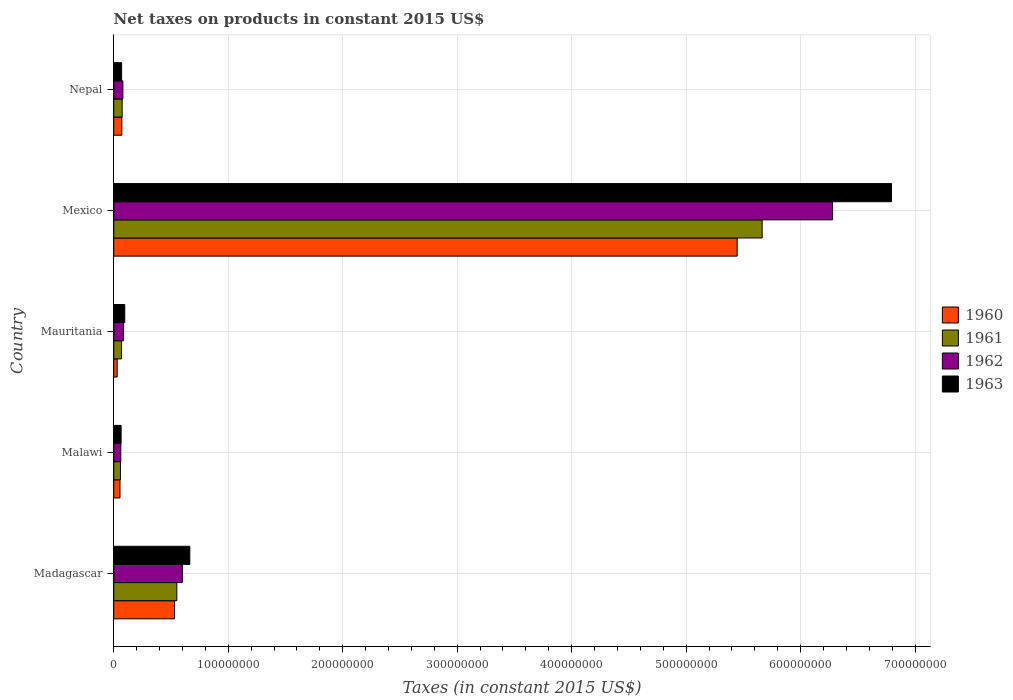Are the number of bars on each tick of the Y-axis equal?
Give a very brief answer. Yes. How many bars are there on the 3rd tick from the bottom?
Keep it short and to the point. 4. What is the label of the 2nd group of bars from the top?
Keep it short and to the point. Mexico. In how many cases, is the number of bars for a given country not equal to the number of legend labels?
Keep it short and to the point. 0. What is the net taxes on products in 1963 in Nepal?
Your response must be concise. 6.89e+06. Across all countries, what is the maximum net taxes on products in 1960?
Provide a short and direct response. 5.45e+08. Across all countries, what is the minimum net taxes on products in 1962?
Your response must be concise. 6.16e+06. In which country was the net taxes on products in 1962 minimum?
Give a very brief answer. Malawi. What is the total net taxes on products in 1961 in the graph?
Give a very brief answer. 6.42e+08. What is the difference between the net taxes on products in 1961 in Mexico and that in Nepal?
Keep it short and to the point. 5.59e+08. What is the difference between the net taxes on products in 1962 in Mauritania and the net taxes on products in 1963 in Nepal?
Give a very brief answer. 1.67e+06. What is the average net taxes on products in 1963 per country?
Provide a succinct answer. 1.54e+08. What is the difference between the net taxes on products in 1963 and net taxes on products in 1962 in Malawi?
Keep it short and to the point. 2.80e+05. In how many countries, is the net taxes on products in 1962 greater than 500000000 US$?
Ensure brevity in your answer.  1. What is the ratio of the net taxes on products in 1963 in Mexico to that in Nepal?
Ensure brevity in your answer.  98.6. Is the difference between the net taxes on products in 1963 in Mauritania and Mexico greater than the difference between the net taxes on products in 1962 in Mauritania and Mexico?
Offer a very short reply. No. What is the difference between the highest and the second highest net taxes on products in 1961?
Offer a terse response. 5.11e+08. What is the difference between the highest and the lowest net taxes on products in 1962?
Give a very brief answer. 6.22e+08. In how many countries, is the net taxes on products in 1960 greater than the average net taxes on products in 1960 taken over all countries?
Offer a very short reply. 1. What does the 3rd bar from the bottom in Madagascar represents?
Your answer should be very brief. 1962. Is it the case that in every country, the sum of the net taxes on products in 1962 and net taxes on products in 1960 is greater than the net taxes on products in 1961?
Provide a succinct answer. Yes. Does the graph contain any zero values?
Provide a succinct answer. No. Does the graph contain grids?
Your response must be concise. Yes. How many legend labels are there?
Offer a terse response. 4. How are the legend labels stacked?
Ensure brevity in your answer.  Vertical. What is the title of the graph?
Make the answer very short. Net taxes on products in constant 2015 US$. Does "1991" appear as one of the legend labels in the graph?
Ensure brevity in your answer.  No. What is the label or title of the X-axis?
Offer a terse response. Taxes (in constant 2015 US$). What is the label or title of the Y-axis?
Offer a very short reply. Country. What is the Taxes (in constant 2015 US$) of 1960 in Madagascar?
Make the answer very short. 5.31e+07. What is the Taxes (in constant 2015 US$) of 1961 in Madagascar?
Ensure brevity in your answer.  5.51e+07. What is the Taxes (in constant 2015 US$) in 1962 in Madagascar?
Your answer should be compact. 6.00e+07. What is the Taxes (in constant 2015 US$) of 1963 in Madagascar?
Your response must be concise. 6.64e+07. What is the Taxes (in constant 2015 US$) of 1960 in Malawi?
Your answer should be compact. 5.46e+06. What is the Taxes (in constant 2015 US$) of 1961 in Malawi?
Provide a succinct answer. 5.88e+06. What is the Taxes (in constant 2015 US$) of 1962 in Malawi?
Give a very brief answer. 6.16e+06. What is the Taxes (in constant 2015 US$) of 1963 in Malawi?
Offer a terse response. 6.44e+06. What is the Taxes (in constant 2015 US$) of 1960 in Mauritania?
Offer a terse response. 3.00e+06. What is the Taxes (in constant 2015 US$) of 1961 in Mauritania?
Make the answer very short. 6.85e+06. What is the Taxes (in constant 2015 US$) of 1962 in Mauritania?
Offer a terse response. 8.56e+06. What is the Taxes (in constant 2015 US$) in 1963 in Mauritania?
Keep it short and to the point. 9.63e+06. What is the Taxes (in constant 2015 US$) of 1960 in Mexico?
Offer a terse response. 5.45e+08. What is the Taxes (in constant 2015 US$) in 1961 in Mexico?
Offer a terse response. 5.66e+08. What is the Taxes (in constant 2015 US$) of 1962 in Mexico?
Your answer should be very brief. 6.28e+08. What is the Taxes (in constant 2015 US$) of 1963 in Mexico?
Provide a succinct answer. 6.79e+08. What is the Taxes (in constant 2015 US$) of 1960 in Nepal?
Make the answer very short. 7.09e+06. What is the Taxes (in constant 2015 US$) in 1961 in Nepal?
Your answer should be compact. 7.35e+06. What is the Taxes (in constant 2015 US$) of 1962 in Nepal?
Make the answer very short. 8.01e+06. What is the Taxes (in constant 2015 US$) in 1963 in Nepal?
Make the answer very short. 6.89e+06. Across all countries, what is the maximum Taxes (in constant 2015 US$) in 1960?
Your answer should be compact. 5.45e+08. Across all countries, what is the maximum Taxes (in constant 2015 US$) of 1961?
Provide a succinct answer. 5.66e+08. Across all countries, what is the maximum Taxes (in constant 2015 US$) in 1962?
Your answer should be very brief. 6.28e+08. Across all countries, what is the maximum Taxes (in constant 2015 US$) in 1963?
Your response must be concise. 6.79e+08. Across all countries, what is the minimum Taxes (in constant 2015 US$) in 1960?
Your response must be concise. 3.00e+06. Across all countries, what is the minimum Taxes (in constant 2015 US$) in 1961?
Give a very brief answer. 5.88e+06. Across all countries, what is the minimum Taxes (in constant 2015 US$) in 1962?
Make the answer very short. 6.16e+06. Across all countries, what is the minimum Taxes (in constant 2015 US$) in 1963?
Ensure brevity in your answer.  6.44e+06. What is the total Taxes (in constant 2015 US$) of 1960 in the graph?
Your answer should be very brief. 6.13e+08. What is the total Taxes (in constant 2015 US$) in 1961 in the graph?
Offer a terse response. 6.42e+08. What is the total Taxes (in constant 2015 US$) in 1962 in the graph?
Your answer should be very brief. 7.11e+08. What is the total Taxes (in constant 2015 US$) of 1963 in the graph?
Provide a succinct answer. 7.69e+08. What is the difference between the Taxes (in constant 2015 US$) in 1960 in Madagascar and that in Malawi?
Make the answer very short. 4.76e+07. What is the difference between the Taxes (in constant 2015 US$) in 1961 in Madagascar and that in Malawi?
Provide a short and direct response. 4.92e+07. What is the difference between the Taxes (in constant 2015 US$) of 1962 in Madagascar and that in Malawi?
Keep it short and to the point. 5.38e+07. What is the difference between the Taxes (in constant 2015 US$) of 1963 in Madagascar and that in Malawi?
Keep it short and to the point. 6.00e+07. What is the difference between the Taxes (in constant 2015 US$) of 1960 in Madagascar and that in Mauritania?
Ensure brevity in your answer.  5.01e+07. What is the difference between the Taxes (in constant 2015 US$) of 1961 in Madagascar and that in Mauritania?
Your answer should be very brief. 4.82e+07. What is the difference between the Taxes (in constant 2015 US$) in 1962 in Madagascar and that in Mauritania?
Make the answer very short. 5.14e+07. What is the difference between the Taxes (in constant 2015 US$) of 1963 in Madagascar and that in Mauritania?
Your answer should be compact. 5.68e+07. What is the difference between the Taxes (in constant 2015 US$) of 1960 in Madagascar and that in Mexico?
Give a very brief answer. -4.91e+08. What is the difference between the Taxes (in constant 2015 US$) of 1961 in Madagascar and that in Mexico?
Provide a succinct answer. -5.11e+08. What is the difference between the Taxes (in constant 2015 US$) in 1962 in Madagascar and that in Mexico?
Offer a very short reply. -5.68e+08. What is the difference between the Taxes (in constant 2015 US$) in 1963 in Madagascar and that in Mexico?
Ensure brevity in your answer.  -6.13e+08. What is the difference between the Taxes (in constant 2015 US$) in 1960 in Madagascar and that in Nepal?
Your answer should be very brief. 4.60e+07. What is the difference between the Taxes (in constant 2015 US$) in 1961 in Madagascar and that in Nepal?
Make the answer very short. 4.77e+07. What is the difference between the Taxes (in constant 2015 US$) in 1962 in Madagascar and that in Nepal?
Your response must be concise. 5.19e+07. What is the difference between the Taxes (in constant 2015 US$) of 1963 in Madagascar and that in Nepal?
Your answer should be compact. 5.95e+07. What is the difference between the Taxes (in constant 2015 US$) of 1960 in Malawi and that in Mauritania?
Your answer should be very brief. 2.46e+06. What is the difference between the Taxes (in constant 2015 US$) in 1961 in Malawi and that in Mauritania?
Provide a short and direct response. -9.67e+05. What is the difference between the Taxes (in constant 2015 US$) in 1962 in Malawi and that in Mauritania?
Make the answer very short. -2.40e+06. What is the difference between the Taxes (in constant 2015 US$) in 1963 in Malawi and that in Mauritania?
Your answer should be compact. -3.19e+06. What is the difference between the Taxes (in constant 2015 US$) in 1960 in Malawi and that in Mexico?
Keep it short and to the point. -5.39e+08. What is the difference between the Taxes (in constant 2015 US$) of 1961 in Malawi and that in Mexico?
Your answer should be compact. -5.61e+08. What is the difference between the Taxes (in constant 2015 US$) of 1962 in Malawi and that in Mexico?
Your response must be concise. -6.22e+08. What is the difference between the Taxes (in constant 2015 US$) of 1963 in Malawi and that in Mexico?
Provide a short and direct response. -6.73e+08. What is the difference between the Taxes (in constant 2015 US$) in 1960 in Malawi and that in Nepal?
Keep it short and to the point. -1.63e+06. What is the difference between the Taxes (in constant 2015 US$) in 1961 in Malawi and that in Nepal?
Ensure brevity in your answer.  -1.47e+06. What is the difference between the Taxes (in constant 2015 US$) in 1962 in Malawi and that in Nepal?
Your answer should be very brief. -1.85e+06. What is the difference between the Taxes (in constant 2015 US$) of 1963 in Malawi and that in Nepal?
Provide a short and direct response. -4.50e+05. What is the difference between the Taxes (in constant 2015 US$) of 1960 in Mauritania and that in Mexico?
Keep it short and to the point. -5.42e+08. What is the difference between the Taxes (in constant 2015 US$) of 1961 in Mauritania and that in Mexico?
Give a very brief answer. -5.60e+08. What is the difference between the Taxes (in constant 2015 US$) of 1962 in Mauritania and that in Mexico?
Your answer should be very brief. -6.19e+08. What is the difference between the Taxes (in constant 2015 US$) in 1963 in Mauritania and that in Mexico?
Make the answer very short. -6.70e+08. What is the difference between the Taxes (in constant 2015 US$) of 1960 in Mauritania and that in Nepal?
Provide a short and direct response. -4.09e+06. What is the difference between the Taxes (in constant 2015 US$) in 1961 in Mauritania and that in Nepal?
Give a very brief answer. -5.03e+05. What is the difference between the Taxes (in constant 2015 US$) in 1962 in Mauritania and that in Nepal?
Provide a succinct answer. 5.53e+05. What is the difference between the Taxes (in constant 2015 US$) of 1963 in Mauritania and that in Nepal?
Give a very brief answer. 2.74e+06. What is the difference between the Taxes (in constant 2015 US$) in 1960 in Mexico and that in Nepal?
Offer a terse response. 5.37e+08. What is the difference between the Taxes (in constant 2015 US$) of 1961 in Mexico and that in Nepal?
Keep it short and to the point. 5.59e+08. What is the difference between the Taxes (in constant 2015 US$) of 1962 in Mexico and that in Nepal?
Offer a terse response. 6.20e+08. What is the difference between the Taxes (in constant 2015 US$) of 1963 in Mexico and that in Nepal?
Keep it short and to the point. 6.72e+08. What is the difference between the Taxes (in constant 2015 US$) in 1960 in Madagascar and the Taxes (in constant 2015 US$) in 1961 in Malawi?
Provide a short and direct response. 4.72e+07. What is the difference between the Taxes (in constant 2015 US$) of 1960 in Madagascar and the Taxes (in constant 2015 US$) of 1962 in Malawi?
Ensure brevity in your answer.  4.69e+07. What is the difference between the Taxes (in constant 2015 US$) of 1960 in Madagascar and the Taxes (in constant 2015 US$) of 1963 in Malawi?
Provide a short and direct response. 4.66e+07. What is the difference between the Taxes (in constant 2015 US$) in 1961 in Madagascar and the Taxes (in constant 2015 US$) in 1962 in Malawi?
Provide a succinct answer. 4.89e+07. What is the difference between the Taxes (in constant 2015 US$) of 1961 in Madagascar and the Taxes (in constant 2015 US$) of 1963 in Malawi?
Provide a succinct answer. 4.87e+07. What is the difference between the Taxes (in constant 2015 US$) in 1962 in Madagascar and the Taxes (in constant 2015 US$) in 1963 in Malawi?
Provide a succinct answer. 5.35e+07. What is the difference between the Taxes (in constant 2015 US$) in 1960 in Madagascar and the Taxes (in constant 2015 US$) in 1961 in Mauritania?
Your response must be concise. 4.62e+07. What is the difference between the Taxes (in constant 2015 US$) in 1960 in Madagascar and the Taxes (in constant 2015 US$) in 1962 in Mauritania?
Ensure brevity in your answer.  4.45e+07. What is the difference between the Taxes (in constant 2015 US$) in 1960 in Madagascar and the Taxes (in constant 2015 US$) in 1963 in Mauritania?
Your response must be concise. 4.34e+07. What is the difference between the Taxes (in constant 2015 US$) of 1961 in Madagascar and the Taxes (in constant 2015 US$) of 1962 in Mauritania?
Your response must be concise. 4.65e+07. What is the difference between the Taxes (in constant 2015 US$) in 1961 in Madagascar and the Taxes (in constant 2015 US$) in 1963 in Mauritania?
Offer a very short reply. 4.55e+07. What is the difference between the Taxes (in constant 2015 US$) of 1962 in Madagascar and the Taxes (in constant 2015 US$) of 1963 in Mauritania?
Keep it short and to the point. 5.03e+07. What is the difference between the Taxes (in constant 2015 US$) in 1960 in Madagascar and the Taxes (in constant 2015 US$) in 1961 in Mexico?
Your response must be concise. -5.13e+08. What is the difference between the Taxes (in constant 2015 US$) in 1960 in Madagascar and the Taxes (in constant 2015 US$) in 1962 in Mexico?
Your response must be concise. -5.75e+08. What is the difference between the Taxes (in constant 2015 US$) of 1960 in Madagascar and the Taxes (in constant 2015 US$) of 1963 in Mexico?
Provide a short and direct response. -6.26e+08. What is the difference between the Taxes (in constant 2015 US$) of 1961 in Madagascar and the Taxes (in constant 2015 US$) of 1962 in Mexico?
Your response must be concise. -5.73e+08. What is the difference between the Taxes (in constant 2015 US$) in 1961 in Madagascar and the Taxes (in constant 2015 US$) in 1963 in Mexico?
Provide a succinct answer. -6.24e+08. What is the difference between the Taxes (in constant 2015 US$) of 1962 in Madagascar and the Taxes (in constant 2015 US$) of 1963 in Mexico?
Offer a very short reply. -6.19e+08. What is the difference between the Taxes (in constant 2015 US$) in 1960 in Madagascar and the Taxes (in constant 2015 US$) in 1961 in Nepal?
Give a very brief answer. 4.57e+07. What is the difference between the Taxes (in constant 2015 US$) in 1960 in Madagascar and the Taxes (in constant 2015 US$) in 1962 in Nepal?
Provide a short and direct response. 4.51e+07. What is the difference between the Taxes (in constant 2015 US$) in 1960 in Madagascar and the Taxes (in constant 2015 US$) in 1963 in Nepal?
Keep it short and to the point. 4.62e+07. What is the difference between the Taxes (in constant 2015 US$) of 1961 in Madagascar and the Taxes (in constant 2015 US$) of 1962 in Nepal?
Ensure brevity in your answer.  4.71e+07. What is the difference between the Taxes (in constant 2015 US$) in 1961 in Madagascar and the Taxes (in constant 2015 US$) in 1963 in Nepal?
Your answer should be compact. 4.82e+07. What is the difference between the Taxes (in constant 2015 US$) in 1962 in Madagascar and the Taxes (in constant 2015 US$) in 1963 in Nepal?
Your answer should be very brief. 5.31e+07. What is the difference between the Taxes (in constant 2015 US$) in 1960 in Malawi and the Taxes (in constant 2015 US$) in 1961 in Mauritania?
Offer a very short reply. -1.39e+06. What is the difference between the Taxes (in constant 2015 US$) in 1960 in Malawi and the Taxes (in constant 2015 US$) in 1962 in Mauritania?
Provide a succinct answer. -3.10e+06. What is the difference between the Taxes (in constant 2015 US$) of 1960 in Malawi and the Taxes (in constant 2015 US$) of 1963 in Mauritania?
Keep it short and to the point. -4.17e+06. What is the difference between the Taxes (in constant 2015 US$) of 1961 in Malawi and the Taxes (in constant 2015 US$) of 1962 in Mauritania?
Ensure brevity in your answer.  -2.68e+06. What is the difference between the Taxes (in constant 2015 US$) in 1961 in Malawi and the Taxes (in constant 2015 US$) in 1963 in Mauritania?
Your answer should be compact. -3.75e+06. What is the difference between the Taxes (in constant 2015 US$) of 1962 in Malawi and the Taxes (in constant 2015 US$) of 1963 in Mauritania?
Provide a short and direct response. -3.47e+06. What is the difference between the Taxes (in constant 2015 US$) in 1960 in Malawi and the Taxes (in constant 2015 US$) in 1961 in Mexico?
Provide a succinct answer. -5.61e+08. What is the difference between the Taxes (in constant 2015 US$) in 1960 in Malawi and the Taxes (in constant 2015 US$) in 1962 in Mexico?
Keep it short and to the point. -6.22e+08. What is the difference between the Taxes (in constant 2015 US$) in 1960 in Malawi and the Taxes (in constant 2015 US$) in 1963 in Mexico?
Provide a succinct answer. -6.74e+08. What is the difference between the Taxes (in constant 2015 US$) in 1961 in Malawi and the Taxes (in constant 2015 US$) in 1962 in Mexico?
Offer a very short reply. -6.22e+08. What is the difference between the Taxes (in constant 2015 US$) of 1961 in Malawi and the Taxes (in constant 2015 US$) of 1963 in Mexico?
Provide a succinct answer. -6.73e+08. What is the difference between the Taxes (in constant 2015 US$) in 1962 in Malawi and the Taxes (in constant 2015 US$) in 1963 in Mexico?
Your response must be concise. -6.73e+08. What is the difference between the Taxes (in constant 2015 US$) in 1960 in Malawi and the Taxes (in constant 2015 US$) in 1961 in Nepal?
Give a very brief answer. -1.89e+06. What is the difference between the Taxes (in constant 2015 US$) in 1960 in Malawi and the Taxes (in constant 2015 US$) in 1962 in Nepal?
Provide a succinct answer. -2.55e+06. What is the difference between the Taxes (in constant 2015 US$) in 1960 in Malawi and the Taxes (in constant 2015 US$) in 1963 in Nepal?
Keep it short and to the point. -1.43e+06. What is the difference between the Taxes (in constant 2015 US$) in 1961 in Malawi and the Taxes (in constant 2015 US$) in 1962 in Nepal?
Keep it short and to the point. -2.13e+06. What is the difference between the Taxes (in constant 2015 US$) in 1961 in Malawi and the Taxes (in constant 2015 US$) in 1963 in Nepal?
Ensure brevity in your answer.  -1.01e+06. What is the difference between the Taxes (in constant 2015 US$) in 1962 in Malawi and the Taxes (in constant 2015 US$) in 1963 in Nepal?
Keep it short and to the point. -7.30e+05. What is the difference between the Taxes (in constant 2015 US$) in 1960 in Mauritania and the Taxes (in constant 2015 US$) in 1961 in Mexico?
Ensure brevity in your answer.  -5.63e+08. What is the difference between the Taxes (in constant 2015 US$) of 1960 in Mauritania and the Taxes (in constant 2015 US$) of 1962 in Mexico?
Your answer should be very brief. -6.25e+08. What is the difference between the Taxes (in constant 2015 US$) of 1960 in Mauritania and the Taxes (in constant 2015 US$) of 1963 in Mexico?
Your response must be concise. -6.76e+08. What is the difference between the Taxes (in constant 2015 US$) of 1961 in Mauritania and the Taxes (in constant 2015 US$) of 1962 in Mexico?
Your answer should be very brief. -6.21e+08. What is the difference between the Taxes (in constant 2015 US$) in 1961 in Mauritania and the Taxes (in constant 2015 US$) in 1963 in Mexico?
Give a very brief answer. -6.73e+08. What is the difference between the Taxes (in constant 2015 US$) in 1962 in Mauritania and the Taxes (in constant 2015 US$) in 1963 in Mexico?
Keep it short and to the point. -6.71e+08. What is the difference between the Taxes (in constant 2015 US$) in 1960 in Mauritania and the Taxes (in constant 2015 US$) in 1961 in Nepal?
Your answer should be very brief. -4.35e+06. What is the difference between the Taxes (in constant 2015 US$) of 1960 in Mauritania and the Taxes (in constant 2015 US$) of 1962 in Nepal?
Keep it short and to the point. -5.01e+06. What is the difference between the Taxes (in constant 2015 US$) of 1960 in Mauritania and the Taxes (in constant 2015 US$) of 1963 in Nepal?
Your response must be concise. -3.89e+06. What is the difference between the Taxes (in constant 2015 US$) of 1961 in Mauritania and the Taxes (in constant 2015 US$) of 1962 in Nepal?
Offer a terse response. -1.16e+06. What is the difference between the Taxes (in constant 2015 US$) of 1961 in Mauritania and the Taxes (in constant 2015 US$) of 1963 in Nepal?
Your answer should be compact. -4.29e+04. What is the difference between the Taxes (in constant 2015 US$) of 1962 in Mauritania and the Taxes (in constant 2015 US$) of 1963 in Nepal?
Ensure brevity in your answer.  1.67e+06. What is the difference between the Taxes (in constant 2015 US$) in 1960 in Mexico and the Taxes (in constant 2015 US$) in 1961 in Nepal?
Offer a terse response. 5.37e+08. What is the difference between the Taxes (in constant 2015 US$) of 1960 in Mexico and the Taxes (in constant 2015 US$) of 1962 in Nepal?
Provide a short and direct response. 5.37e+08. What is the difference between the Taxes (in constant 2015 US$) in 1960 in Mexico and the Taxes (in constant 2015 US$) in 1963 in Nepal?
Provide a short and direct response. 5.38e+08. What is the difference between the Taxes (in constant 2015 US$) in 1961 in Mexico and the Taxes (in constant 2015 US$) in 1962 in Nepal?
Your answer should be compact. 5.58e+08. What is the difference between the Taxes (in constant 2015 US$) of 1961 in Mexico and the Taxes (in constant 2015 US$) of 1963 in Nepal?
Offer a terse response. 5.60e+08. What is the difference between the Taxes (in constant 2015 US$) of 1962 in Mexico and the Taxes (in constant 2015 US$) of 1963 in Nepal?
Offer a very short reply. 6.21e+08. What is the average Taxes (in constant 2015 US$) of 1960 per country?
Offer a terse response. 1.23e+08. What is the average Taxes (in constant 2015 US$) of 1961 per country?
Your answer should be compact. 1.28e+08. What is the average Taxes (in constant 2015 US$) in 1962 per country?
Offer a terse response. 1.42e+08. What is the average Taxes (in constant 2015 US$) of 1963 per country?
Make the answer very short. 1.54e+08. What is the difference between the Taxes (in constant 2015 US$) in 1960 and Taxes (in constant 2015 US$) in 1961 in Madagascar?
Your answer should be very brief. -2.03e+06. What is the difference between the Taxes (in constant 2015 US$) of 1960 and Taxes (in constant 2015 US$) of 1962 in Madagascar?
Make the answer very short. -6.89e+06. What is the difference between the Taxes (in constant 2015 US$) in 1960 and Taxes (in constant 2015 US$) in 1963 in Madagascar?
Give a very brief answer. -1.34e+07. What is the difference between the Taxes (in constant 2015 US$) of 1961 and Taxes (in constant 2015 US$) of 1962 in Madagascar?
Offer a very short reply. -4.86e+06. What is the difference between the Taxes (in constant 2015 US$) of 1961 and Taxes (in constant 2015 US$) of 1963 in Madagascar?
Ensure brevity in your answer.  -1.13e+07. What is the difference between the Taxes (in constant 2015 US$) of 1962 and Taxes (in constant 2015 US$) of 1963 in Madagascar?
Your response must be concise. -6.48e+06. What is the difference between the Taxes (in constant 2015 US$) in 1960 and Taxes (in constant 2015 US$) in 1961 in Malawi?
Give a very brief answer. -4.20e+05. What is the difference between the Taxes (in constant 2015 US$) in 1960 and Taxes (in constant 2015 US$) in 1962 in Malawi?
Give a very brief answer. -7.00e+05. What is the difference between the Taxes (in constant 2015 US$) of 1960 and Taxes (in constant 2015 US$) of 1963 in Malawi?
Ensure brevity in your answer.  -9.80e+05. What is the difference between the Taxes (in constant 2015 US$) of 1961 and Taxes (in constant 2015 US$) of 1962 in Malawi?
Ensure brevity in your answer.  -2.80e+05. What is the difference between the Taxes (in constant 2015 US$) of 1961 and Taxes (in constant 2015 US$) of 1963 in Malawi?
Provide a succinct answer. -5.60e+05. What is the difference between the Taxes (in constant 2015 US$) in 1962 and Taxes (in constant 2015 US$) in 1963 in Malawi?
Offer a terse response. -2.80e+05. What is the difference between the Taxes (in constant 2015 US$) in 1960 and Taxes (in constant 2015 US$) in 1961 in Mauritania?
Keep it short and to the point. -3.85e+06. What is the difference between the Taxes (in constant 2015 US$) in 1960 and Taxes (in constant 2015 US$) in 1962 in Mauritania?
Give a very brief answer. -5.56e+06. What is the difference between the Taxes (in constant 2015 US$) of 1960 and Taxes (in constant 2015 US$) of 1963 in Mauritania?
Provide a succinct answer. -6.63e+06. What is the difference between the Taxes (in constant 2015 US$) of 1961 and Taxes (in constant 2015 US$) of 1962 in Mauritania?
Provide a short and direct response. -1.71e+06. What is the difference between the Taxes (in constant 2015 US$) in 1961 and Taxes (in constant 2015 US$) in 1963 in Mauritania?
Offer a terse response. -2.78e+06. What is the difference between the Taxes (in constant 2015 US$) of 1962 and Taxes (in constant 2015 US$) of 1963 in Mauritania?
Offer a terse response. -1.07e+06. What is the difference between the Taxes (in constant 2015 US$) in 1960 and Taxes (in constant 2015 US$) in 1961 in Mexico?
Offer a very short reply. -2.18e+07. What is the difference between the Taxes (in constant 2015 US$) in 1960 and Taxes (in constant 2015 US$) in 1962 in Mexico?
Provide a short and direct response. -8.34e+07. What is the difference between the Taxes (in constant 2015 US$) in 1960 and Taxes (in constant 2015 US$) in 1963 in Mexico?
Your answer should be compact. -1.35e+08. What is the difference between the Taxes (in constant 2015 US$) of 1961 and Taxes (in constant 2015 US$) of 1962 in Mexico?
Keep it short and to the point. -6.15e+07. What is the difference between the Taxes (in constant 2015 US$) of 1961 and Taxes (in constant 2015 US$) of 1963 in Mexico?
Give a very brief answer. -1.13e+08. What is the difference between the Taxes (in constant 2015 US$) in 1962 and Taxes (in constant 2015 US$) in 1963 in Mexico?
Give a very brief answer. -5.14e+07. What is the difference between the Taxes (in constant 2015 US$) in 1960 and Taxes (in constant 2015 US$) in 1961 in Nepal?
Your answer should be compact. -2.63e+05. What is the difference between the Taxes (in constant 2015 US$) in 1960 and Taxes (in constant 2015 US$) in 1962 in Nepal?
Offer a terse response. -9.19e+05. What is the difference between the Taxes (in constant 2015 US$) in 1960 and Taxes (in constant 2015 US$) in 1963 in Nepal?
Keep it short and to the point. 1.97e+05. What is the difference between the Taxes (in constant 2015 US$) in 1961 and Taxes (in constant 2015 US$) in 1962 in Nepal?
Offer a very short reply. -6.56e+05. What is the difference between the Taxes (in constant 2015 US$) of 1961 and Taxes (in constant 2015 US$) of 1963 in Nepal?
Provide a short and direct response. 4.60e+05. What is the difference between the Taxes (in constant 2015 US$) of 1962 and Taxes (in constant 2015 US$) of 1963 in Nepal?
Offer a very short reply. 1.12e+06. What is the ratio of the Taxes (in constant 2015 US$) of 1960 in Madagascar to that in Malawi?
Ensure brevity in your answer.  9.72. What is the ratio of the Taxes (in constant 2015 US$) in 1961 in Madagascar to that in Malawi?
Offer a very short reply. 9.37. What is the ratio of the Taxes (in constant 2015 US$) of 1962 in Madagascar to that in Malawi?
Give a very brief answer. 9.73. What is the ratio of the Taxes (in constant 2015 US$) in 1963 in Madagascar to that in Malawi?
Provide a succinct answer. 10.32. What is the ratio of the Taxes (in constant 2015 US$) in 1960 in Madagascar to that in Mauritania?
Your response must be concise. 17.72. What is the ratio of the Taxes (in constant 2015 US$) of 1961 in Madagascar to that in Mauritania?
Provide a short and direct response. 8.05. What is the ratio of the Taxes (in constant 2015 US$) of 1962 in Madagascar to that in Mauritania?
Provide a succinct answer. 7. What is the ratio of the Taxes (in constant 2015 US$) in 1963 in Madagascar to that in Mauritania?
Offer a terse response. 6.9. What is the ratio of the Taxes (in constant 2015 US$) of 1960 in Madagascar to that in Mexico?
Your response must be concise. 0.1. What is the ratio of the Taxes (in constant 2015 US$) of 1961 in Madagascar to that in Mexico?
Provide a succinct answer. 0.1. What is the ratio of the Taxes (in constant 2015 US$) in 1962 in Madagascar to that in Mexico?
Give a very brief answer. 0.1. What is the ratio of the Taxes (in constant 2015 US$) of 1963 in Madagascar to that in Mexico?
Ensure brevity in your answer.  0.1. What is the ratio of the Taxes (in constant 2015 US$) of 1960 in Madagascar to that in Nepal?
Give a very brief answer. 7.49. What is the ratio of the Taxes (in constant 2015 US$) in 1961 in Madagascar to that in Nepal?
Your answer should be compact. 7.5. What is the ratio of the Taxes (in constant 2015 US$) in 1962 in Madagascar to that in Nepal?
Your answer should be very brief. 7.49. What is the ratio of the Taxes (in constant 2015 US$) in 1963 in Madagascar to that in Nepal?
Ensure brevity in your answer.  9.64. What is the ratio of the Taxes (in constant 2015 US$) in 1960 in Malawi to that in Mauritania?
Keep it short and to the point. 1.82. What is the ratio of the Taxes (in constant 2015 US$) of 1961 in Malawi to that in Mauritania?
Ensure brevity in your answer.  0.86. What is the ratio of the Taxes (in constant 2015 US$) of 1962 in Malawi to that in Mauritania?
Give a very brief answer. 0.72. What is the ratio of the Taxes (in constant 2015 US$) in 1963 in Malawi to that in Mauritania?
Keep it short and to the point. 0.67. What is the ratio of the Taxes (in constant 2015 US$) in 1960 in Malawi to that in Mexico?
Your answer should be very brief. 0.01. What is the ratio of the Taxes (in constant 2015 US$) of 1961 in Malawi to that in Mexico?
Your answer should be very brief. 0.01. What is the ratio of the Taxes (in constant 2015 US$) in 1962 in Malawi to that in Mexico?
Ensure brevity in your answer.  0.01. What is the ratio of the Taxes (in constant 2015 US$) of 1963 in Malawi to that in Mexico?
Offer a very short reply. 0.01. What is the ratio of the Taxes (in constant 2015 US$) in 1960 in Malawi to that in Nepal?
Make the answer very short. 0.77. What is the ratio of the Taxes (in constant 2015 US$) of 1962 in Malawi to that in Nepal?
Provide a succinct answer. 0.77. What is the ratio of the Taxes (in constant 2015 US$) of 1963 in Malawi to that in Nepal?
Your answer should be compact. 0.93. What is the ratio of the Taxes (in constant 2015 US$) in 1960 in Mauritania to that in Mexico?
Ensure brevity in your answer.  0.01. What is the ratio of the Taxes (in constant 2015 US$) of 1961 in Mauritania to that in Mexico?
Keep it short and to the point. 0.01. What is the ratio of the Taxes (in constant 2015 US$) in 1962 in Mauritania to that in Mexico?
Offer a very short reply. 0.01. What is the ratio of the Taxes (in constant 2015 US$) of 1963 in Mauritania to that in Mexico?
Provide a short and direct response. 0.01. What is the ratio of the Taxes (in constant 2015 US$) of 1960 in Mauritania to that in Nepal?
Provide a succinct answer. 0.42. What is the ratio of the Taxes (in constant 2015 US$) in 1961 in Mauritania to that in Nepal?
Ensure brevity in your answer.  0.93. What is the ratio of the Taxes (in constant 2015 US$) in 1962 in Mauritania to that in Nepal?
Offer a very short reply. 1.07. What is the ratio of the Taxes (in constant 2015 US$) in 1963 in Mauritania to that in Nepal?
Offer a very short reply. 1.4. What is the ratio of the Taxes (in constant 2015 US$) in 1960 in Mexico to that in Nepal?
Keep it short and to the point. 76.83. What is the ratio of the Taxes (in constant 2015 US$) in 1961 in Mexico to that in Nepal?
Provide a short and direct response. 77.06. What is the ratio of the Taxes (in constant 2015 US$) in 1962 in Mexico to that in Nepal?
Make the answer very short. 78.43. What is the ratio of the Taxes (in constant 2015 US$) of 1963 in Mexico to that in Nepal?
Make the answer very short. 98.6. What is the difference between the highest and the second highest Taxes (in constant 2015 US$) in 1960?
Provide a short and direct response. 4.91e+08. What is the difference between the highest and the second highest Taxes (in constant 2015 US$) in 1961?
Your answer should be compact. 5.11e+08. What is the difference between the highest and the second highest Taxes (in constant 2015 US$) in 1962?
Your response must be concise. 5.68e+08. What is the difference between the highest and the second highest Taxes (in constant 2015 US$) of 1963?
Provide a short and direct response. 6.13e+08. What is the difference between the highest and the lowest Taxes (in constant 2015 US$) of 1960?
Give a very brief answer. 5.42e+08. What is the difference between the highest and the lowest Taxes (in constant 2015 US$) of 1961?
Make the answer very short. 5.61e+08. What is the difference between the highest and the lowest Taxes (in constant 2015 US$) of 1962?
Ensure brevity in your answer.  6.22e+08. What is the difference between the highest and the lowest Taxes (in constant 2015 US$) in 1963?
Provide a succinct answer. 6.73e+08. 